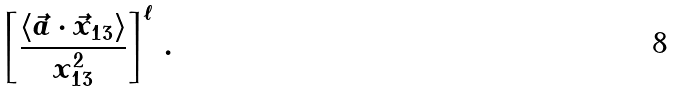Convert formula to latex. <formula><loc_0><loc_0><loc_500><loc_500>\left [ \frac { \langle \vec { a } \cdot \vec { x } _ { 1 3 } \rangle } { x ^ { 2 } _ { 1 3 } } \right ] ^ { \ell } \, .</formula> 